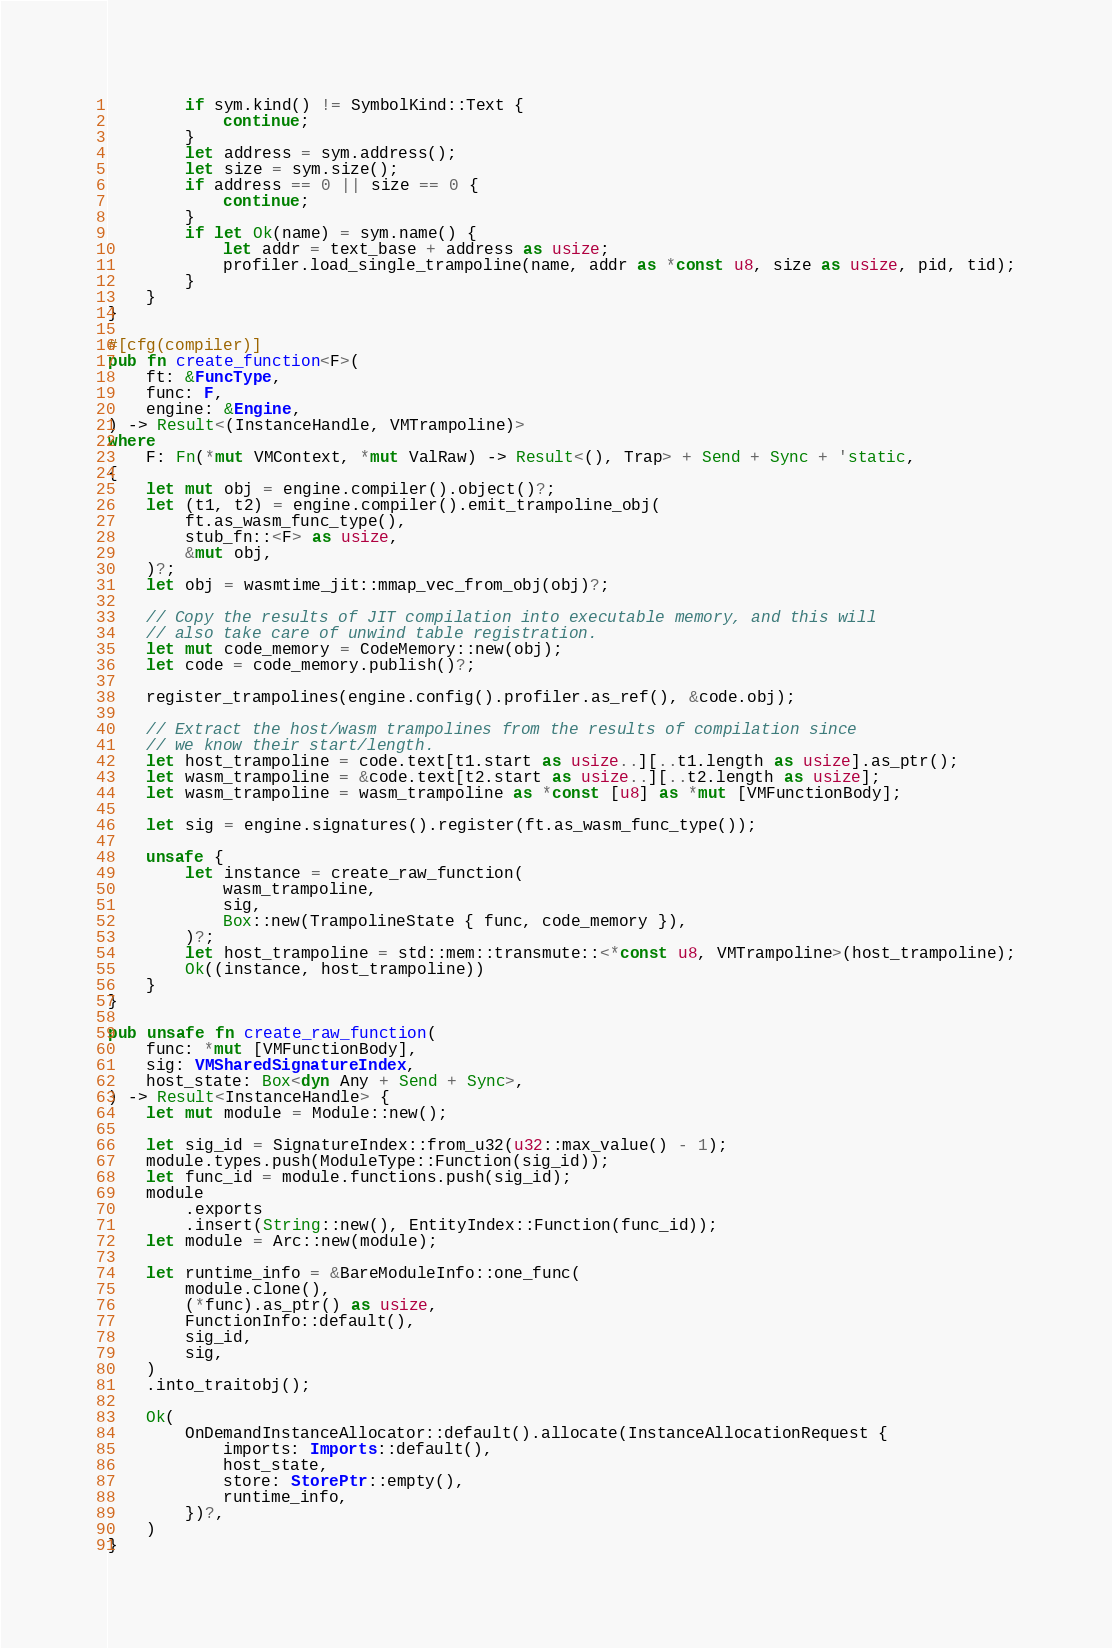Convert code to text. <code><loc_0><loc_0><loc_500><loc_500><_Rust_>        if sym.kind() != SymbolKind::Text {
            continue;
        }
        let address = sym.address();
        let size = sym.size();
        if address == 0 || size == 0 {
            continue;
        }
        if let Ok(name) = sym.name() {
            let addr = text_base + address as usize;
            profiler.load_single_trampoline(name, addr as *const u8, size as usize, pid, tid);
        }
    }
}

#[cfg(compiler)]
pub fn create_function<F>(
    ft: &FuncType,
    func: F,
    engine: &Engine,
) -> Result<(InstanceHandle, VMTrampoline)>
where
    F: Fn(*mut VMContext, *mut ValRaw) -> Result<(), Trap> + Send + Sync + 'static,
{
    let mut obj = engine.compiler().object()?;
    let (t1, t2) = engine.compiler().emit_trampoline_obj(
        ft.as_wasm_func_type(),
        stub_fn::<F> as usize,
        &mut obj,
    )?;
    let obj = wasmtime_jit::mmap_vec_from_obj(obj)?;

    // Copy the results of JIT compilation into executable memory, and this will
    // also take care of unwind table registration.
    let mut code_memory = CodeMemory::new(obj);
    let code = code_memory.publish()?;

    register_trampolines(engine.config().profiler.as_ref(), &code.obj);

    // Extract the host/wasm trampolines from the results of compilation since
    // we know their start/length.
    let host_trampoline = code.text[t1.start as usize..][..t1.length as usize].as_ptr();
    let wasm_trampoline = &code.text[t2.start as usize..][..t2.length as usize];
    let wasm_trampoline = wasm_trampoline as *const [u8] as *mut [VMFunctionBody];

    let sig = engine.signatures().register(ft.as_wasm_func_type());

    unsafe {
        let instance = create_raw_function(
            wasm_trampoline,
            sig,
            Box::new(TrampolineState { func, code_memory }),
        )?;
        let host_trampoline = std::mem::transmute::<*const u8, VMTrampoline>(host_trampoline);
        Ok((instance, host_trampoline))
    }
}

pub unsafe fn create_raw_function(
    func: *mut [VMFunctionBody],
    sig: VMSharedSignatureIndex,
    host_state: Box<dyn Any + Send + Sync>,
) -> Result<InstanceHandle> {
    let mut module = Module::new();

    let sig_id = SignatureIndex::from_u32(u32::max_value() - 1);
    module.types.push(ModuleType::Function(sig_id));
    let func_id = module.functions.push(sig_id);
    module
        .exports
        .insert(String::new(), EntityIndex::Function(func_id));
    let module = Arc::new(module);

    let runtime_info = &BareModuleInfo::one_func(
        module.clone(),
        (*func).as_ptr() as usize,
        FunctionInfo::default(),
        sig_id,
        sig,
    )
    .into_traitobj();

    Ok(
        OnDemandInstanceAllocator::default().allocate(InstanceAllocationRequest {
            imports: Imports::default(),
            host_state,
            store: StorePtr::empty(),
            runtime_info,
        })?,
    )
}
</code> 